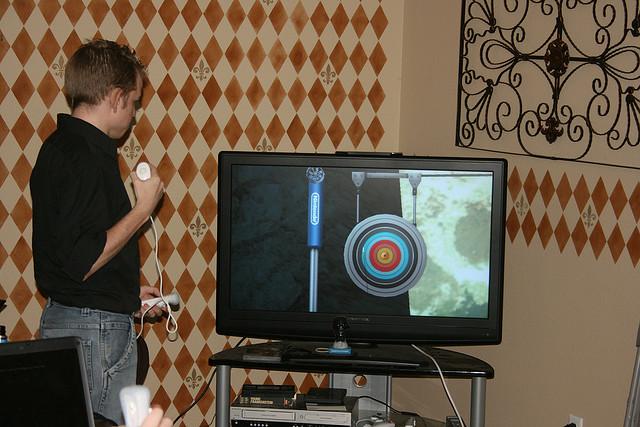What color shirt is the man wearing?
Give a very brief answer. Black. How many people are in the audience?
Answer briefly. 0. Is this a flat screen TV?
Be succinct. Yes. Is the TV on a table?
Answer briefly. Yes. Which video game is the man playing?
Answer briefly. Archery. What is painted on the wall on the far left side of the picture?
Keep it brief. Diamonds. 